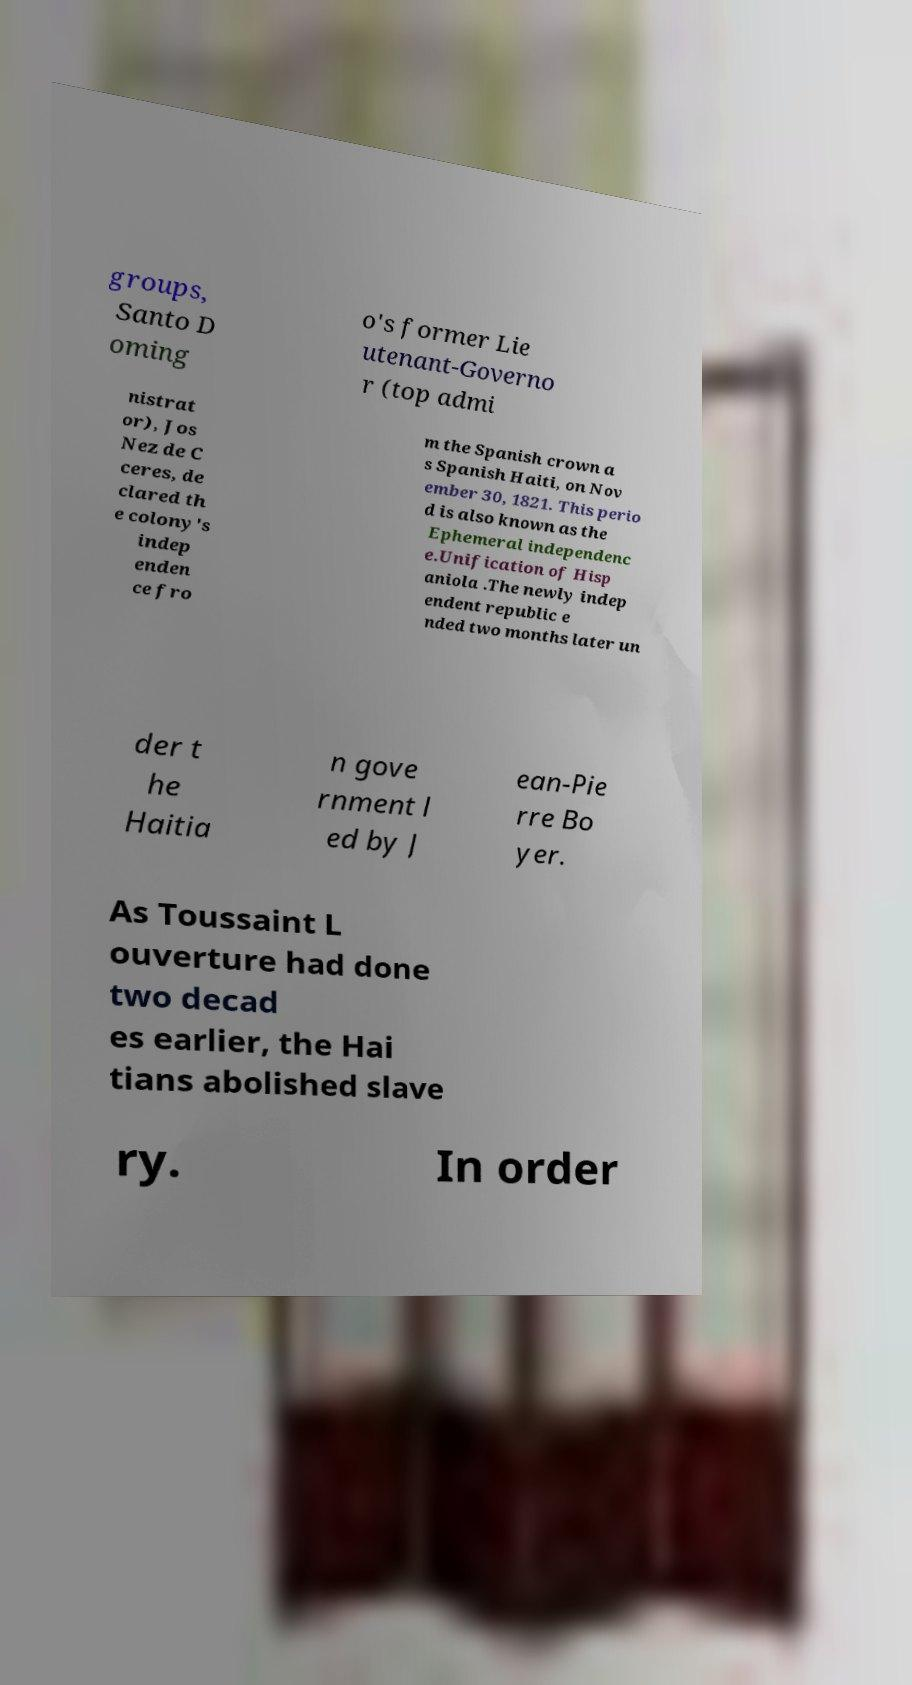Could you assist in decoding the text presented in this image and type it out clearly? groups, Santo D oming o's former Lie utenant-Governo r (top admi nistrat or), Jos Nez de C ceres, de clared th e colony's indep enden ce fro m the Spanish crown a s Spanish Haiti, on Nov ember 30, 1821. This perio d is also known as the Ephemeral independenc e.Unification of Hisp aniola .The newly indep endent republic e nded two months later un der t he Haitia n gove rnment l ed by J ean-Pie rre Bo yer. As Toussaint L ouverture had done two decad es earlier, the Hai tians abolished slave ry. In order 